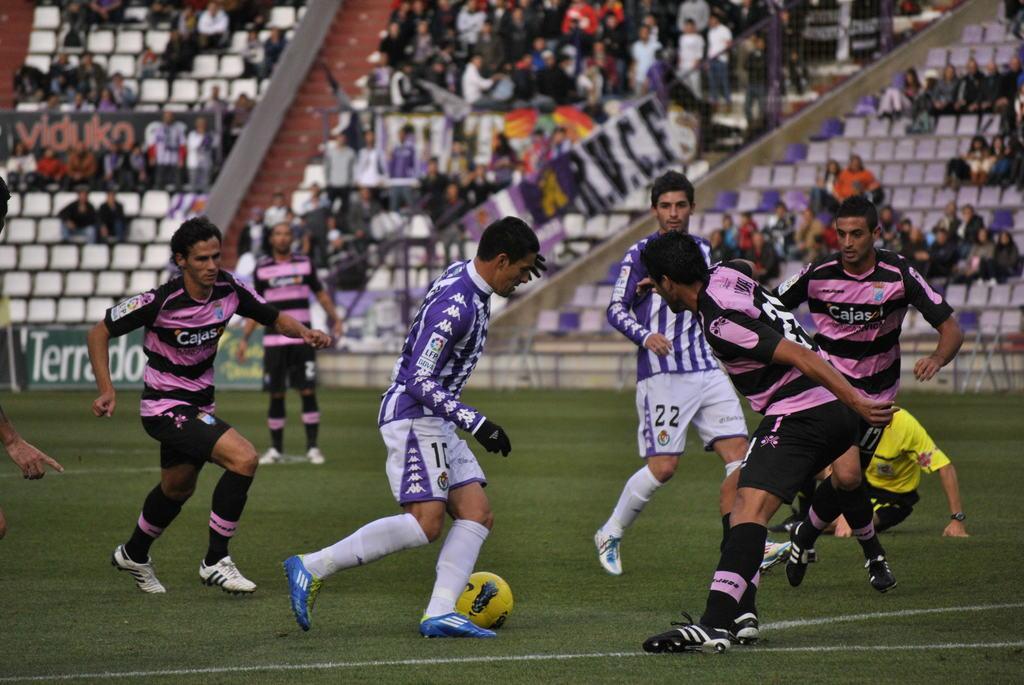Describe this image in one or two sentences. A group of people are playing the foot ball, middle a person is trying to kick the football. He wore a purple color and white color dress, blue color shoes. 